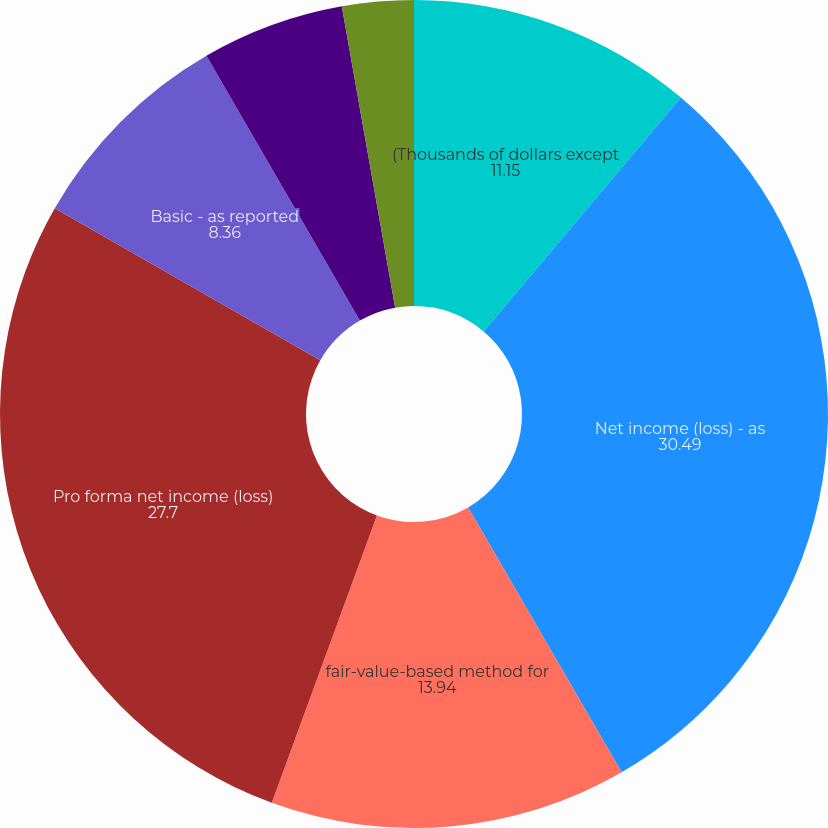Convert chart to OTSL. <chart><loc_0><loc_0><loc_500><loc_500><pie_chart><fcel>(Thousands of dollars except<fcel>Net income (loss) - as<fcel>fair-value-based method for<fcel>Pro forma net income (loss)<fcel>Basic - as reported<fcel>Basic - pro forma<fcel>Diluted - as reported<fcel>Diluted - pro forma<nl><fcel>11.15%<fcel>30.49%<fcel>13.94%<fcel>27.7%<fcel>8.36%<fcel>5.57%<fcel>2.79%<fcel>0.0%<nl></chart> 